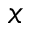<formula> <loc_0><loc_0><loc_500><loc_500>x</formula> 